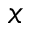<formula> <loc_0><loc_0><loc_500><loc_500>x</formula> 